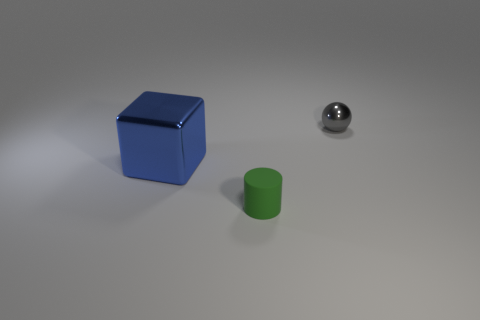The blue thing that is the same material as the small gray ball is what size?
Provide a short and direct response. Large. What number of rubber things are gray spheres or big blue things?
Make the answer very short. 0. What is the size of the blue cube?
Keep it short and to the point. Large. Is the size of the green rubber thing the same as the blue block?
Your answer should be very brief. No. What is the material of the tiny thing that is behind the blue shiny thing?
Your response must be concise. Metal. Is there a big blue thing that is on the right side of the metallic thing on the right side of the tiny green object?
Provide a succinct answer. No. Is the blue object the same shape as the matte thing?
Your response must be concise. No. What is the shape of the small gray thing that is the same material as the blue thing?
Your response must be concise. Sphere. Is the size of the shiny object that is in front of the metallic sphere the same as the metal object that is behind the blue object?
Make the answer very short. No. Is the number of big blue things in front of the green cylinder greater than the number of gray shiny objects that are in front of the big blue block?
Make the answer very short. No. 